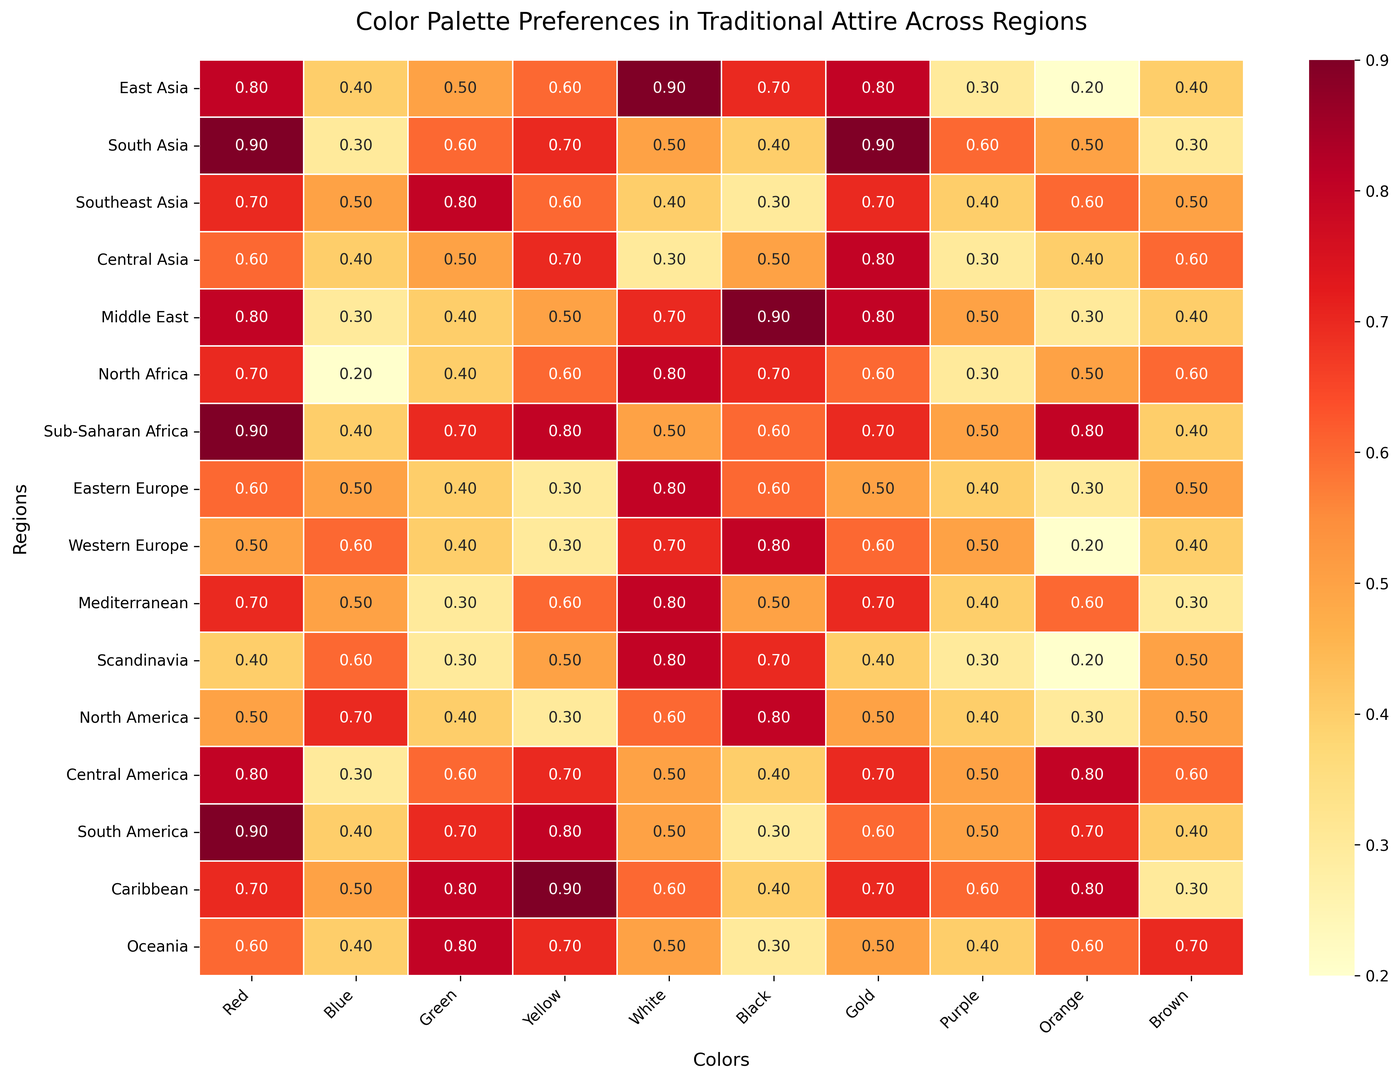What region has the highest preference for the color red? By examining the heatmap, observe the values for the red color across all regions. The highest value for red is 0.9, which appears in multiple regions (South Asia, Sub-Saharan Africa, South America).
Answer: South Asia, Sub-Saharan Africa, South America Which region shows the least preference for the color blue? Look at the blue column and identify the lowest value. The lowest value for blue is 0.2, which corresponds to the North Africa region.
Answer: North Africa How does the preference for green in Southeast Asia compare to that in Central Asia? Identify the values for green in both Southeast Asia (0.8) and Central Asia (0.5). Compare the two values. 0.8 is greater than 0.5, so Southeast Asia has a higher preference.
Answer: Southeast Asia is higher What is the average preference for the color yellow across all regions? Add all the values for the yellow column: 0.6 + 0.7 + 0.6 + 0.7 + 0.5 + 0.6 + 0.8 + 0.3 + 0.3 + 0.6 + 0.5 + 0.3 + 0.7 + 0.8 + 0.9 + 0.7 = 9.9. Then, divide by the number of regions, which is 16. The average preference is 9.9/16 = 0.61875.
Answer: 0.62 Which color shows the highest overall preference in East Asia? For East Asia, compare the preference values for all colors: Red (0.8), Blue (0.4), Green (0.5), Yellow (0.6), White (0.9), Black (0.7), Gold (0.8), Purple (0.3), Orange (0.2), Brown (0.4). The highest value is 0.9 for White.
Answer: White What region shows equal preference for Yellow and Orange? Find the region where the values for yellow and orange are the same. In Central Asia, yellow and orange both have a value of 0.7.
Answer: Central Asia Compare the preferences for gold between the Middle East and Mediterranean regions. The values for gold in the Middle East (0.8) and Mediterranean (0.7) are close, but 0.8 in the Middle East is slightly higher than 0.7 in Mediterranean.
Answer: Middle East is higher What color does Sub-Saharan Africa have the highest preference for, and what is its value? Look at the values in Sub-Saharan Africa row, find the highest value: Red (0.9), Blue (0.4), Green (0.7), Yellow (0.8), White (0.5), Black (0.6), Gold (0.7), Purple (0.5), Orange (0.8), Brown (0.4). The highest value is for Red and Orange, both 0.9.
Answer: Red and Orange, 0.9 Which region has the lowest preference for black, and what is its value? Identify the lowest value in the black column. The lowest value is 0.3 for Southeast Asia, South America, and Oceania.
Answer: Southeast Asia, South America, Oceania, 0.3 What's the difference in preference for white between East Asia and Western Europe? Subtract the white preference value in Western Europe (0.7) from that in East Asia (0.9): 0.9 - 0.7 = 0.2.
Answer: 0.2 